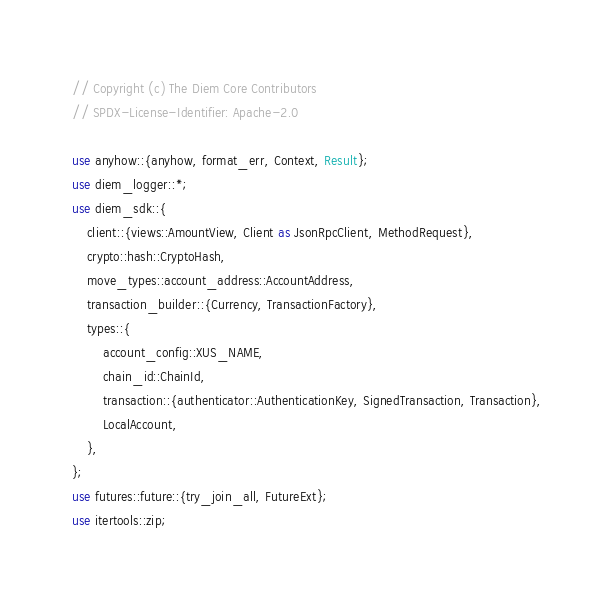<code> <loc_0><loc_0><loc_500><loc_500><_Rust_>// Copyright (c) The Diem Core Contributors
// SPDX-License-Identifier: Apache-2.0

use anyhow::{anyhow, format_err, Context, Result};
use diem_logger::*;
use diem_sdk::{
    client::{views::AmountView, Client as JsonRpcClient, MethodRequest},
    crypto::hash::CryptoHash,
    move_types::account_address::AccountAddress,
    transaction_builder::{Currency, TransactionFactory},
    types::{
        account_config::XUS_NAME,
        chain_id::ChainId,
        transaction::{authenticator::AuthenticationKey, SignedTransaction, Transaction},
        LocalAccount,
    },
};
use futures::future::{try_join_all, FutureExt};
use itertools::zip;</code> 